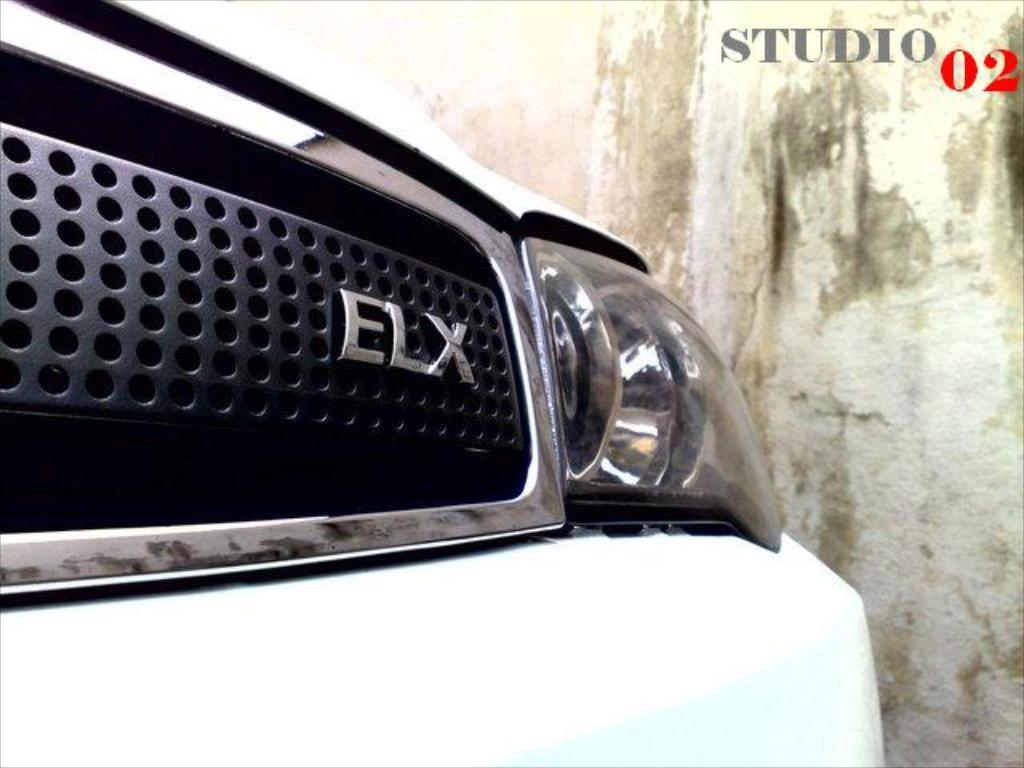What is the main subject in the center of the image? There is a car in the center of the image. What can be seen in the background of the image? There is a wall in the background of the image. What is the rhythm of the church bells in the image? There is no church or bells present in the image, so it is not possible to determine the rhythm of any church bells. 